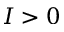Convert formula to latex. <formula><loc_0><loc_0><loc_500><loc_500>I > 0</formula> 